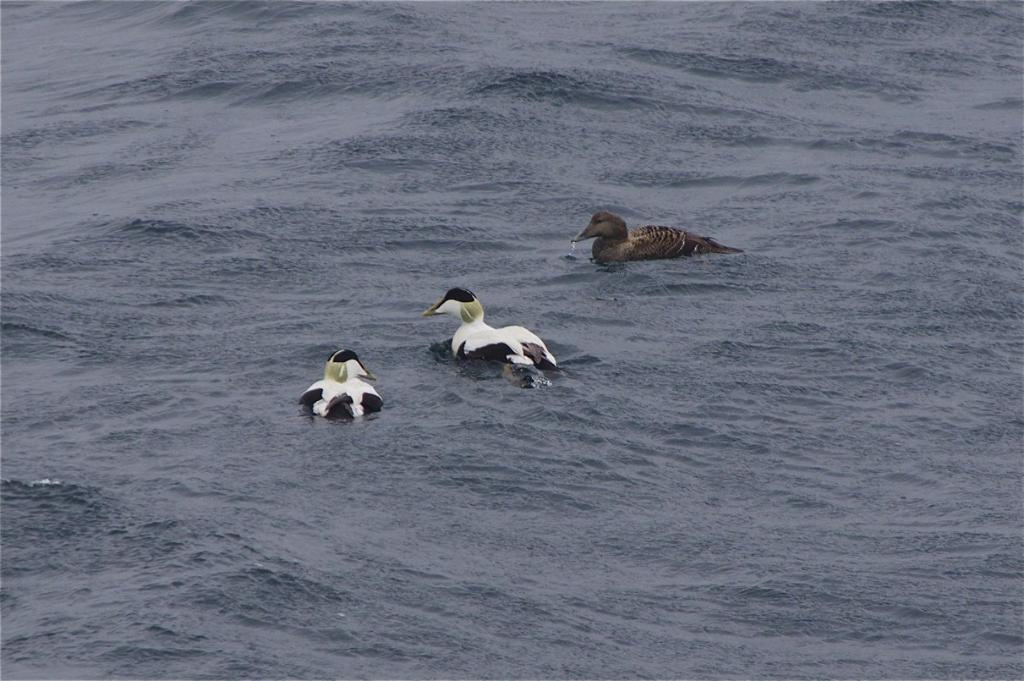What type of animals can be seen in the image? Birds can be seen in the image. What colors are the birds in the image? The birds are in brown, white, and black colors. What type of destruction can be seen in the image? There is no destruction present in the image; it features birds in the water. 